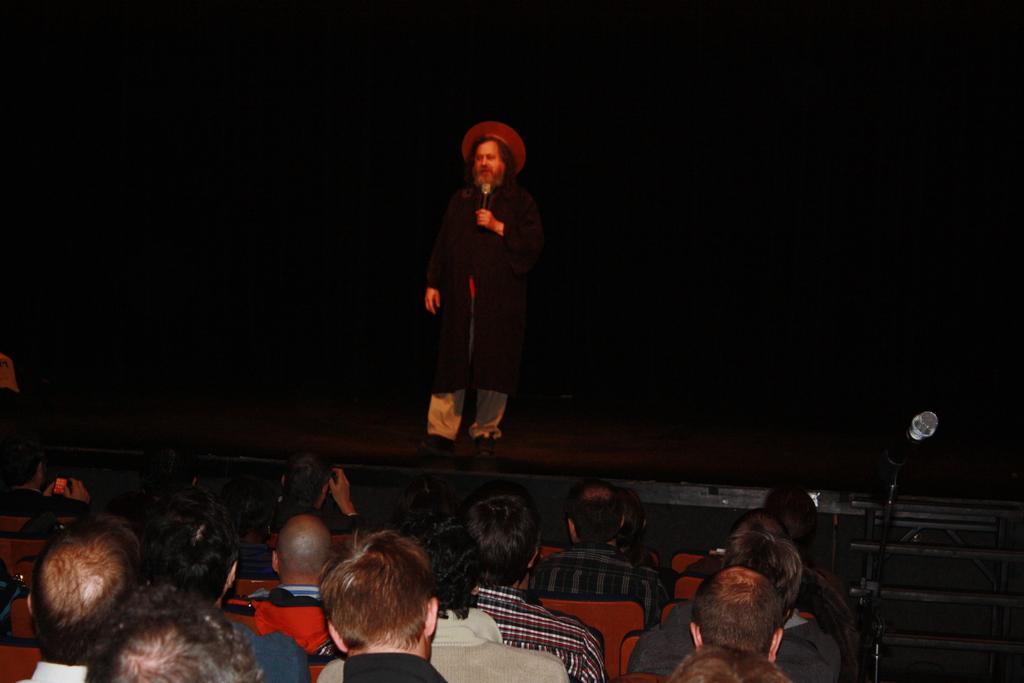Could you give a brief overview of what you see in this image? In this picture I can see a man standing on the dais and a man speaking with the help of a microphone and he wore a hat on his head and I can see few people seated on the chairs and I can see stairs and another microphone to the stand on the right side and I can see black color background. 